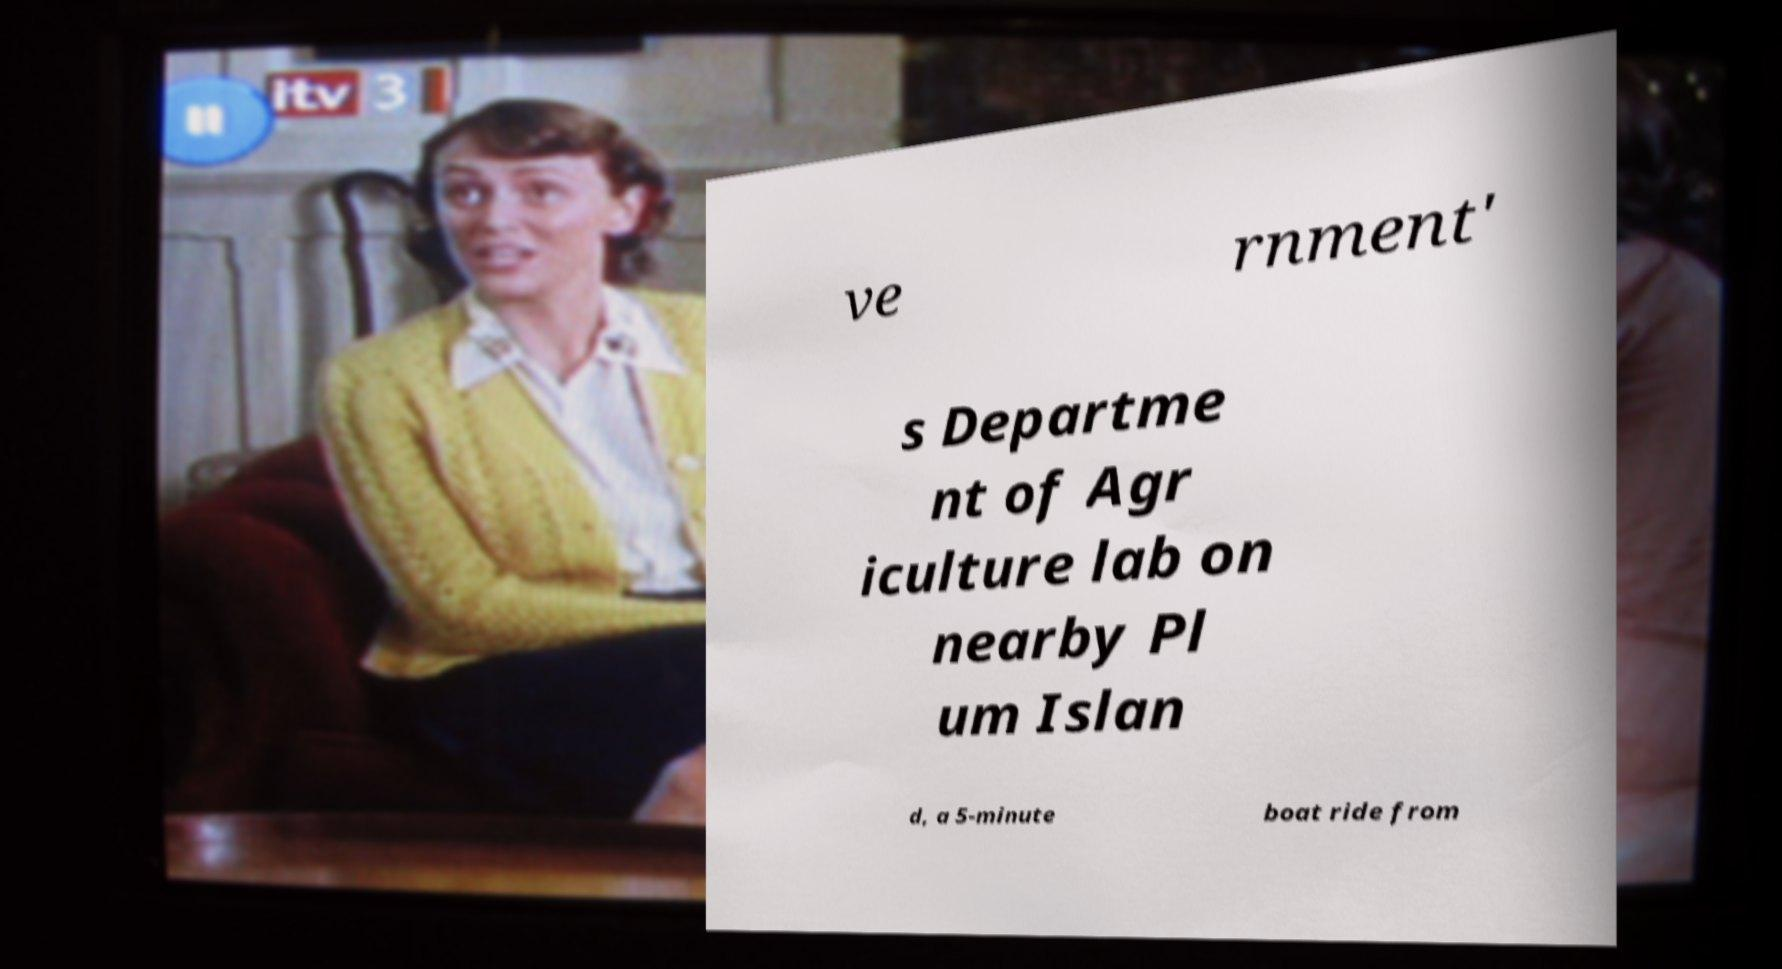I need the written content from this picture converted into text. Can you do that? ve rnment' s Departme nt of Agr iculture lab on nearby Pl um Islan d, a 5-minute boat ride from 